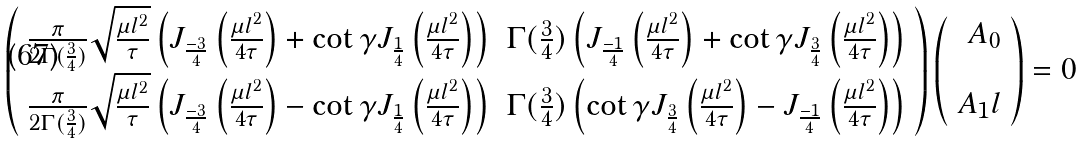Convert formula to latex. <formula><loc_0><loc_0><loc_500><loc_500>\left ( \begin{array} { r r } \frac { \pi } { 2 \Gamma ( \frac { 3 } { 4 } ) } \sqrt { \frac { \mu l ^ { 2 } } { \tau } } \left ( J _ { \frac { - 3 } { 4 } } \left ( \frac { \mu l ^ { 2 } } { 4 \tau } \right ) + \cot \gamma J _ { \frac { 1 } { 4 } } \left ( \frac { \mu l ^ { 2 } } { 4 \tau } \right ) \right ) & \Gamma ( \frac { 3 } { 4 } ) \left ( J _ { \frac { - 1 } { 4 } } \left ( \frac { \mu l ^ { 2 } } { 4 \tau } \right ) + \cot \gamma J _ { \frac { 3 } { 4 } } \left ( \frac { \mu l ^ { 2 } } { 4 \tau } \right ) \right ) \\ \frac { \pi } { 2 \Gamma ( \frac { 3 } { 4 } ) } \sqrt { \frac { \mu l ^ { 2 } } { \tau } } \left ( J _ { \frac { - 3 } { 4 } } \left ( \frac { \mu l ^ { 2 } } { 4 \tau } \right ) - \cot \gamma J _ { \frac { 1 } { 4 } } \left ( \frac { \mu l ^ { 2 } } { 4 \tau } \right ) \right ) & \Gamma ( \frac { 3 } { 4 } ) \left ( \cot \gamma J _ { \frac { 3 } { 4 } } \left ( \frac { \mu l ^ { 2 } } { 4 \tau } \right ) - J _ { \frac { - 1 } { 4 } } \left ( \frac { \mu l ^ { 2 } } { 4 \tau } \right ) \right ) \\ \end{array} \right ) \left ( \begin{array} { r } A _ { 0 } \\ \\ A _ { 1 } l \\ \end{array} \right ) = 0 \\ \\</formula> 